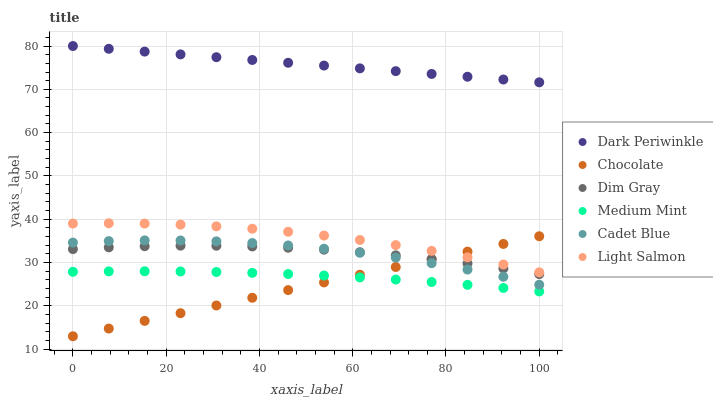Does Chocolate have the minimum area under the curve?
Answer yes or no. Yes. Does Dark Periwinkle have the maximum area under the curve?
Answer yes or no. Yes. Does Light Salmon have the minimum area under the curve?
Answer yes or no. No. Does Light Salmon have the maximum area under the curve?
Answer yes or no. No. Is Chocolate the smoothest?
Answer yes or no. Yes. Is Cadet Blue the roughest?
Answer yes or no. Yes. Is Light Salmon the smoothest?
Answer yes or no. No. Is Light Salmon the roughest?
Answer yes or no. No. Does Chocolate have the lowest value?
Answer yes or no. Yes. Does Light Salmon have the lowest value?
Answer yes or no. No. Does Dark Periwinkle have the highest value?
Answer yes or no. Yes. Does Light Salmon have the highest value?
Answer yes or no. No. Is Medium Mint less than Light Salmon?
Answer yes or no. Yes. Is Dark Periwinkle greater than Chocolate?
Answer yes or no. Yes. Does Cadet Blue intersect Dim Gray?
Answer yes or no. Yes. Is Cadet Blue less than Dim Gray?
Answer yes or no. No. Is Cadet Blue greater than Dim Gray?
Answer yes or no. No. Does Medium Mint intersect Light Salmon?
Answer yes or no. No. 